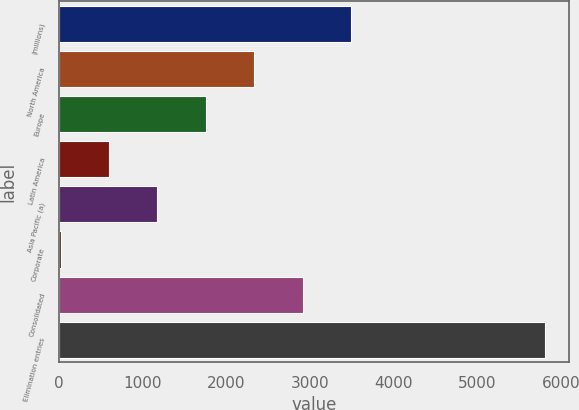Convert chart. <chart><loc_0><loc_0><loc_500><loc_500><bar_chart><fcel>(millions)<fcel>North America<fcel>Europe<fcel>Latin America<fcel>Asia Pacific (a)<fcel>Corporate<fcel>Consolidated<fcel>Elimination entries<nl><fcel>3492.06<fcel>2333.84<fcel>1754.73<fcel>596.51<fcel>1175.62<fcel>17.4<fcel>2912.95<fcel>5808.5<nl></chart> 